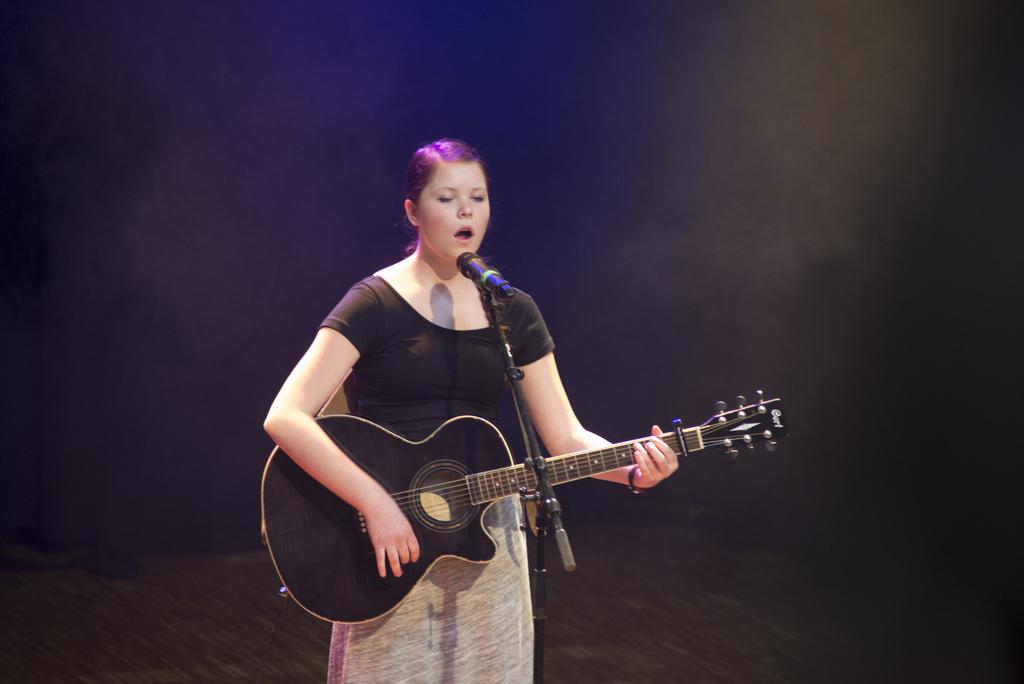Who is the main subject in the image? There is a woman in the image. Where is the woman positioned in the image? The woman is standing in the center. What is the woman doing in the image? The woman is playing a guitar and singing on a microphone. What type of blade is the woman using to cut the sandwich in the image? There is no sandwich or blade present in the image; the woman is playing a guitar and singing on a microphone. 